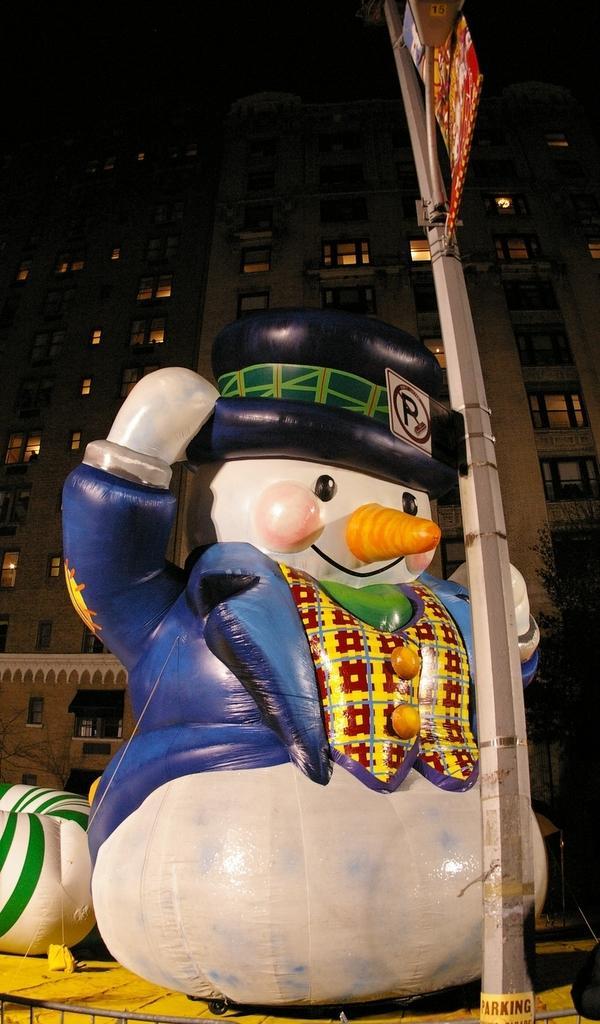Please provide a concise description of this image. Here I can see a balloon toy which is placed on a wooden bench. In front of this there is a pole. In the background, I can see a building along with the windows. 